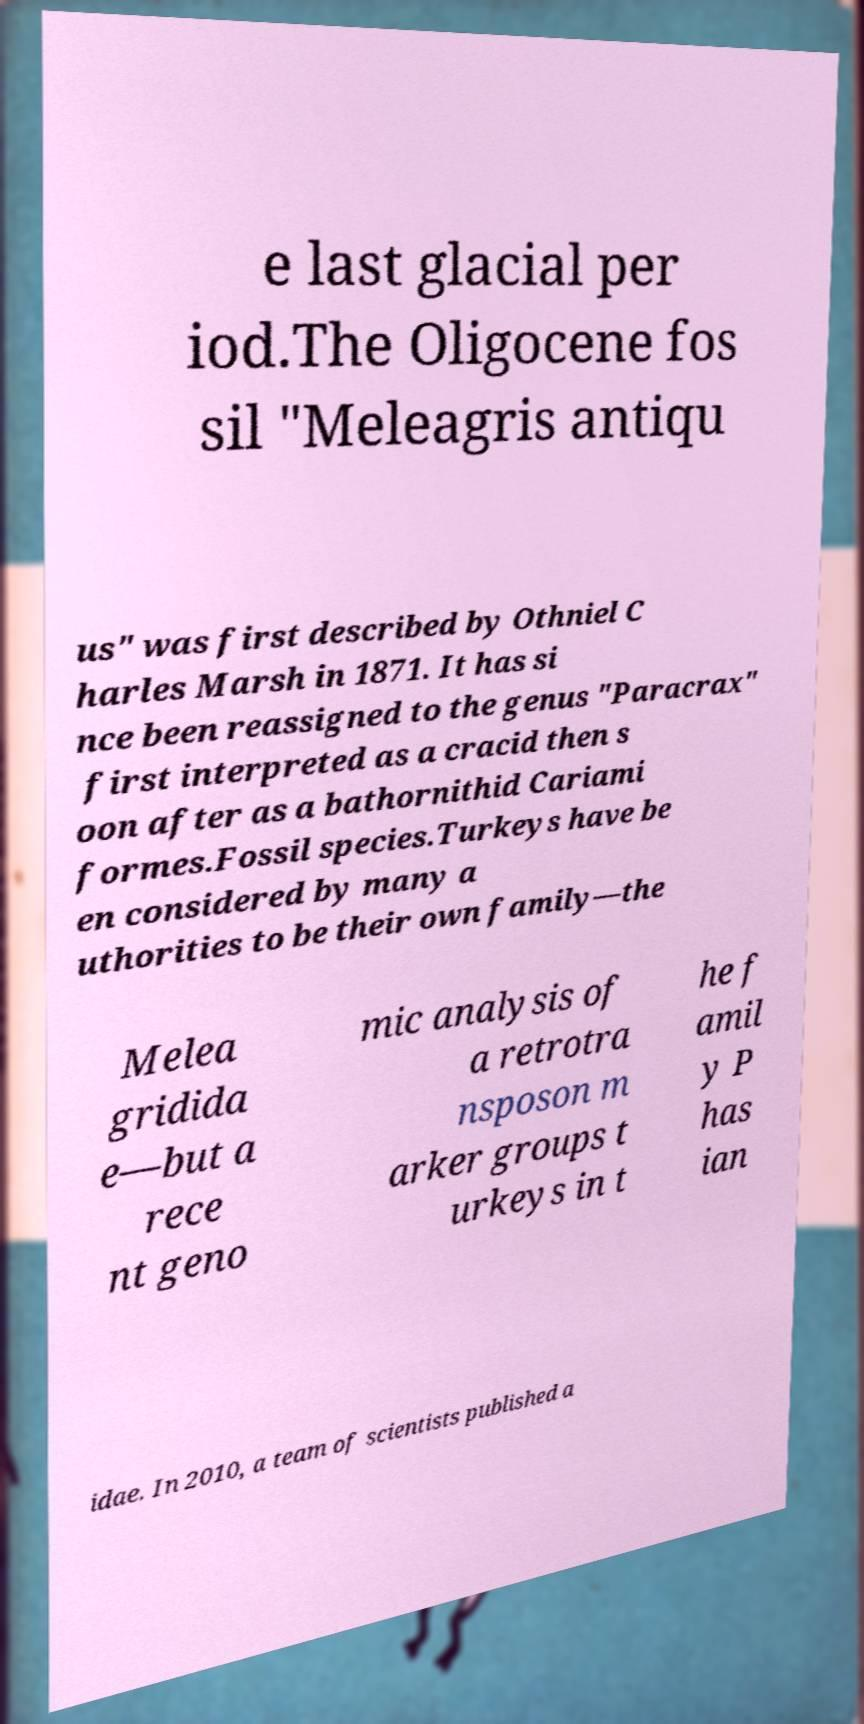For documentation purposes, I need the text within this image transcribed. Could you provide that? e last glacial per iod.The Oligocene fos sil "Meleagris antiqu us" was first described by Othniel C harles Marsh in 1871. It has si nce been reassigned to the genus "Paracrax" first interpreted as a cracid then s oon after as a bathornithid Cariami formes.Fossil species.Turkeys have be en considered by many a uthorities to be their own family—the Melea gridida e—but a rece nt geno mic analysis of a retrotra nsposon m arker groups t urkeys in t he f amil y P has ian idae. In 2010, a team of scientists published a 